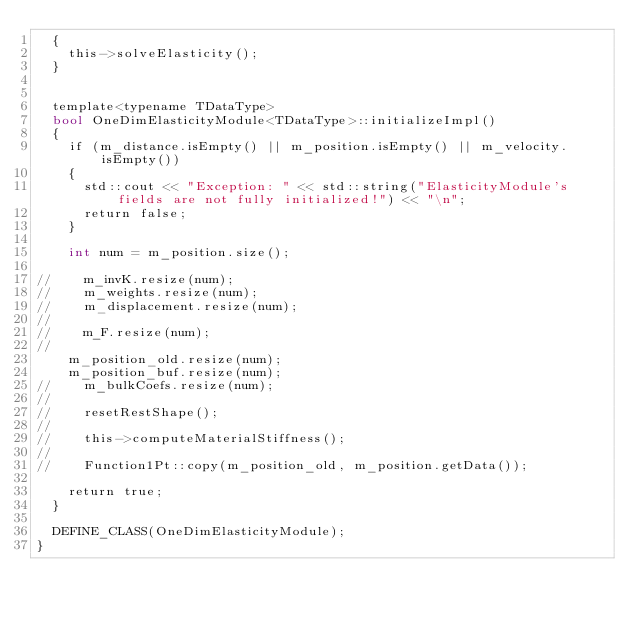Convert code to text. <code><loc_0><loc_0><loc_500><loc_500><_Cuda_>	{
		this->solveElasticity();
	}


	template<typename TDataType>
	bool OneDimElasticityModule<TDataType>::initializeImpl()
	{
		if (m_distance.isEmpty() || m_position.isEmpty() || m_velocity.isEmpty())
		{
			std::cout << "Exception: " << std::string("ElasticityModule's fields are not fully initialized!") << "\n";
			return false;
		}

		int num = m_position.size();
		
// 		m_invK.resize(num);
// 		m_weights.resize(num);
// 		m_displacement.resize(num);
// 
// 		m_F.resize(num);
// 		
 		m_position_old.resize(num);
		m_position_buf.resize(num);
// 		m_bulkCoefs.resize(num);
// 
// 		resetRestShape();
// 
// 		this->computeMaterialStiffness();
// 
// 		Function1Pt::copy(m_position_old, m_position.getData());

		return true;
	}

	DEFINE_CLASS(OneDimElasticityModule);
}</code> 